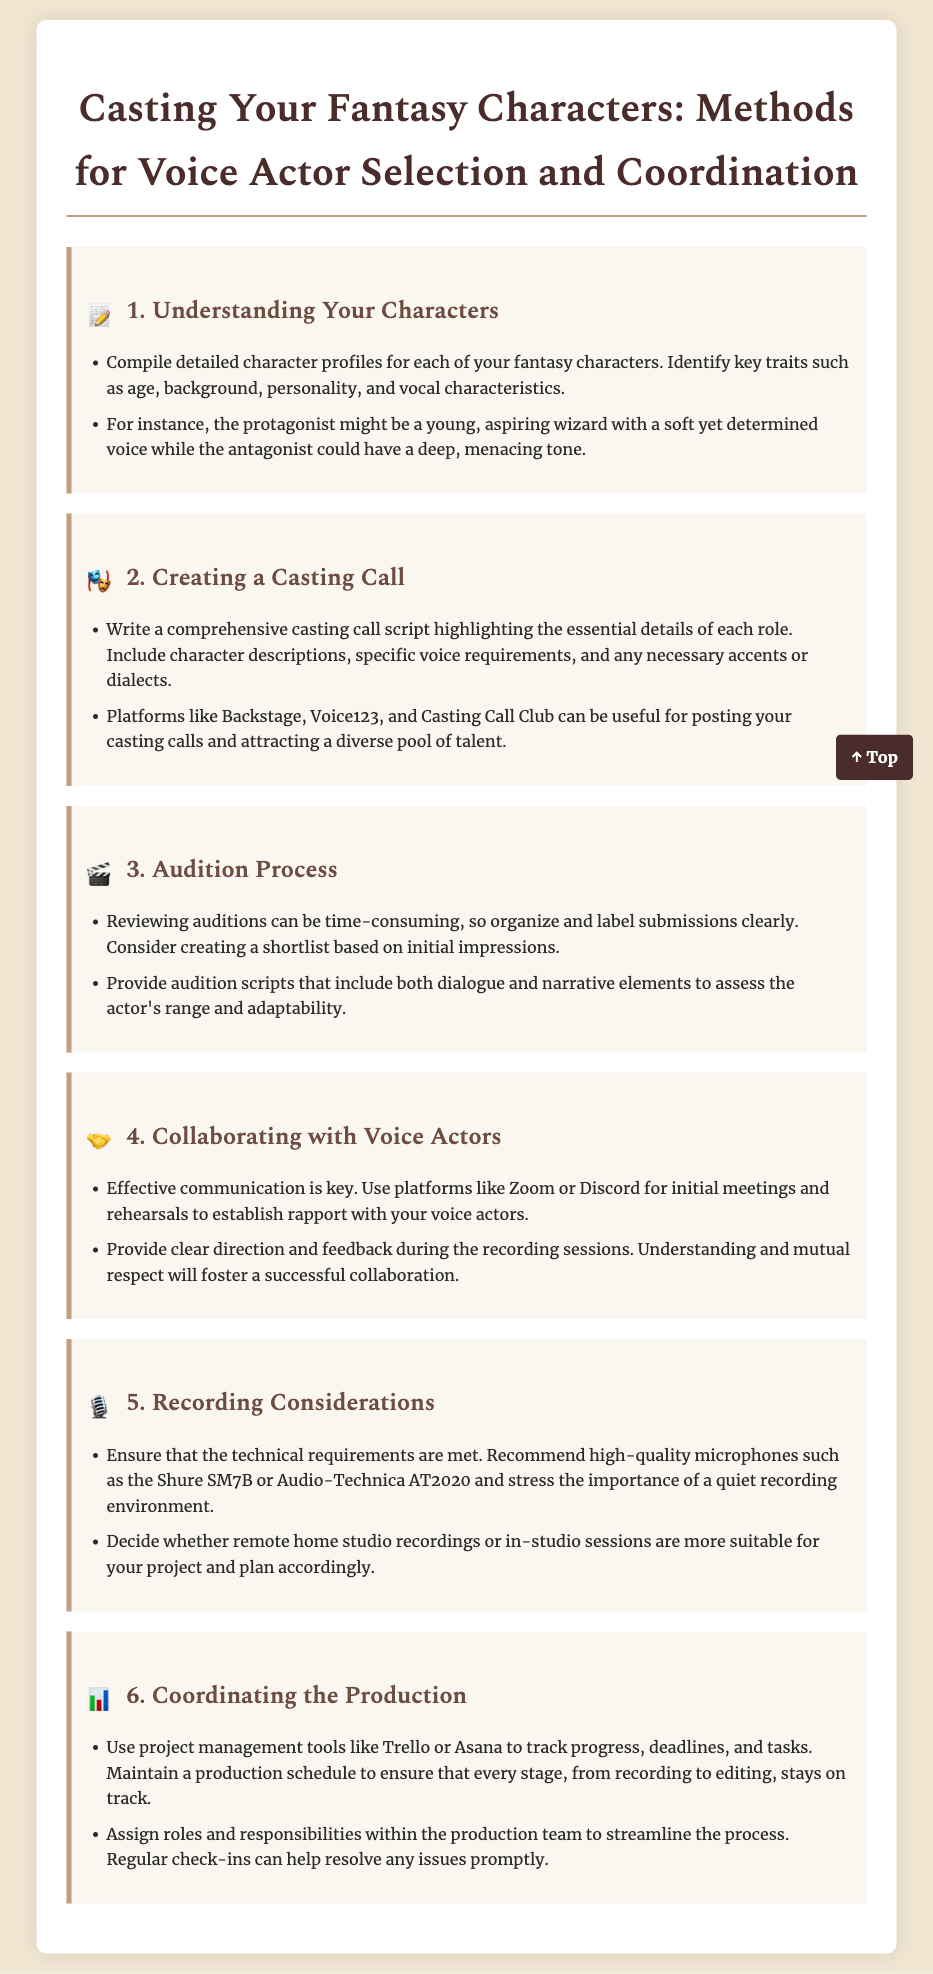what is the title of the document? The title is stated at the top of the document as "Casting Your Fantasy Characters: Methods for Voice Actor Selection and Coordination."
Answer: Casting Your Fantasy Characters: Methods for Voice Actor Selection and Coordination how many main sections are there in the document? The document contains six main sections, each focusing on a different aspect of voice actor selection and coordination.
Answer: 6 what is a recommended platform for posting casting calls? The document suggests several platforms for posting casting calls, specifically mentioning Backstage, Voice123, and Casting Call Club.
Answer: Backstage which microphone is recommended for recording? The document recommends high-quality microphones, specifically mentioning the Shure SM7B.
Answer: Shure SM7B what tool can be used to coordinate production tasks? The document mentions using project management tools, specifically naming Trello and Asana for tracking progress and tasks.
Answer: Trello what is essential for effective communication with voice actors? The document emphasizes that effective communication is key and suggests using platforms like Zoom or Discord for initial meetings.
Answer: Effective communication what should audition scripts include? The document states that audition scripts should include both dialogue and narrative elements to assess the actor's range.
Answer: Dialogue and narrative elements 